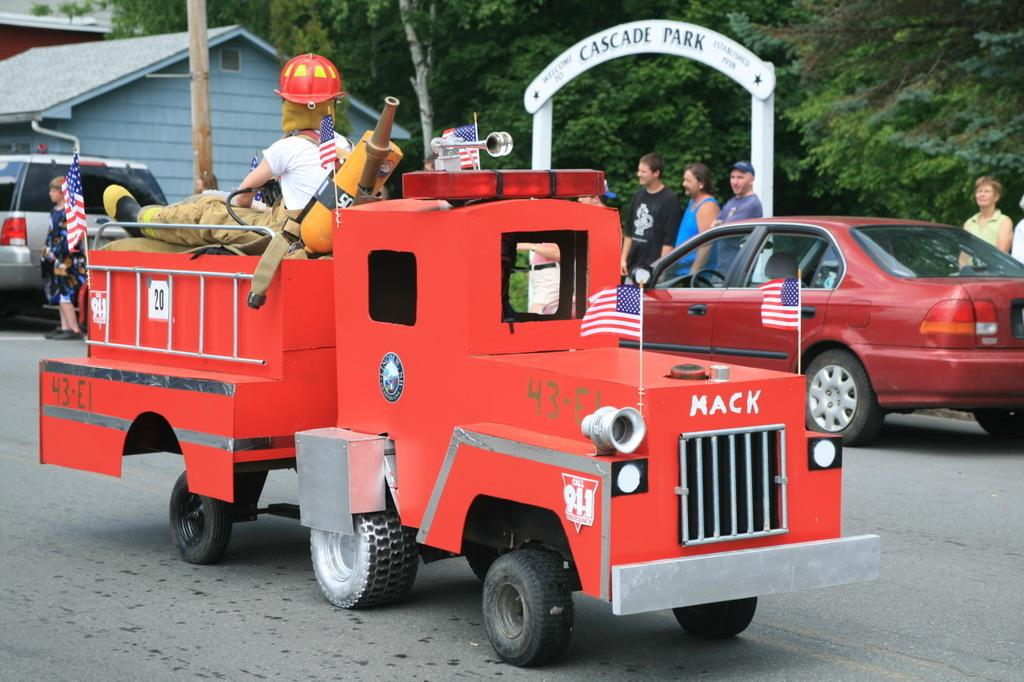What color are the vehicles in the image? The vehicles in the image are red. Where are the vehicles located? The vehicles are on the road. What can be seen in the background of the image? There are people and trees visible in the background of the image. How many brothers are flying the kite in the image? There is no kite or brothers present in the image. What type of loaf is being used to propel the vehicles in the image? There is no loaf or propulsion method mentioned in the image; the vehicles are on the road. 